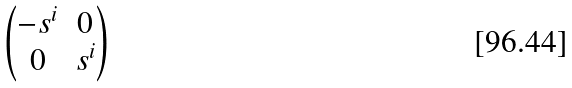Convert formula to latex. <formula><loc_0><loc_0><loc_500><loc_500>\begin{pmatrix} - s ^ { i } & 0 \\ 0 & s ^ { i } \end{pmatrix}</formula> 